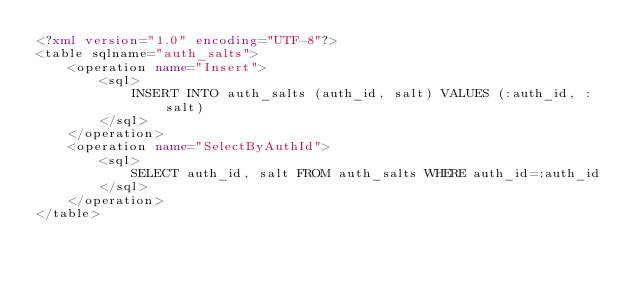<code> <loc_0><loc_0><loc_500><loc_500><_XML_><?xml version="1.0" encoding="UTF-8"?>
<table sqlname="auth_salts">
    <operation name="Insert">
        <sql>
            INSERT INTO auth_salts (auth_id, salt) VALUES (:auth_id, :salt)
        </sql>
    </operation>
    <operation name="SelectByAuthId">
        <sql>
            SELECT auth_id, salt FROM auth_salts WHERE auth_id=:auth_id
        </sql>
    </operation>
</table>
</code> 